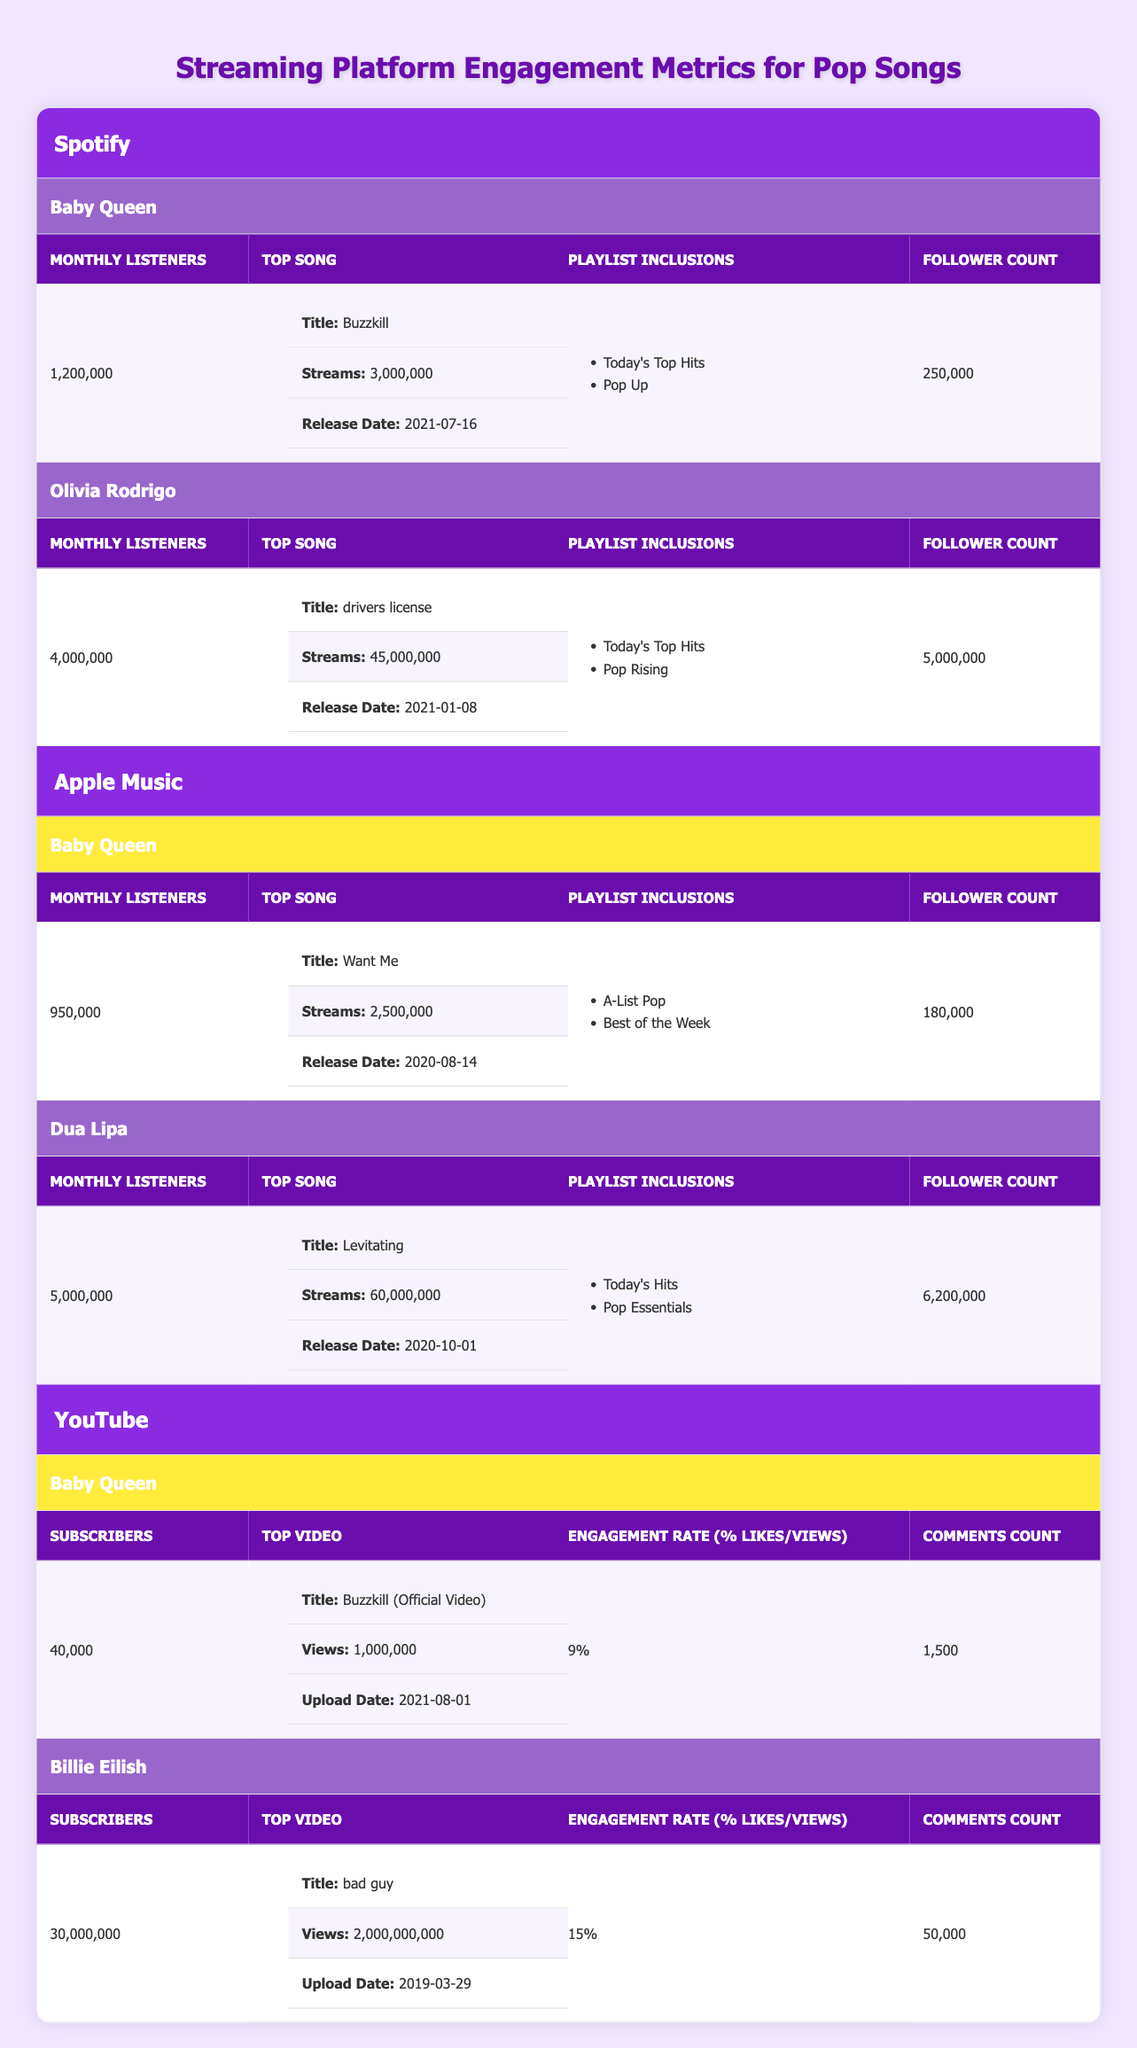What is Baby Queen's top song on Spotify? Baby Queen's top song on Spotify is listed as "Buzzkill," according to the information provided in the Spotify section of the table.
Answer: Buzzkill How many monthly listeners does Olivia Rodrigo have on Spotify? The table indicates that Olivia Rodrigo has 4,000,000 monthly listeners on Spotify.
Answer: 4,000,000 Which artist has the highest number of monthly listeners on Apple Music? In the Apple Music section of the table, Dua Lipa has 5,000,000 monthly listeners, which is higher than Baby Queen's 950,000. Thus, Dua Lipa has the highest number.
Answer: Dua Lipa How many total followers do Baby Queen have across both Spotify and Apple Music? Baby Queen has 250,000 followers on Spotify and 180,000 on Apple Music. By adding these, we get 250,000 + 180,000 = 430,000 followers in total.
Answer: 430,000 Is Baby Queen's engagement rate on YouTube greater than 10%? The table shows Baby Queen's engagement rate is 9%, which is less than 10%. Thus, the statement is false.
Answer: No What is the average number of monthly listeners for Baby Queen across both Spotify and Apple Music? Baby Queen has 1,200,000 monthly listeners on Spotify and 950,000 on Apple Music. The average can be calculated as (1,200,000 + 950,000) / 2 = 1,075,000.
Answer: 1,075,000 What was the release date of Baby Queen's top song on Apple Music? Baby Queen's top song on Apple Music is "Want Me," which has a release date of August 14, 2020, according to the data in the table.
Answer: August 14, 2020 Does Billie Eilish have a higher engagement rate on YouTube compared to Baby Queen? Billie Eilish has an engagement rate of 15%, while Baby Queen's is 9%. Since 15% is greater than 9%, the statement is true.
Answer: Yes 